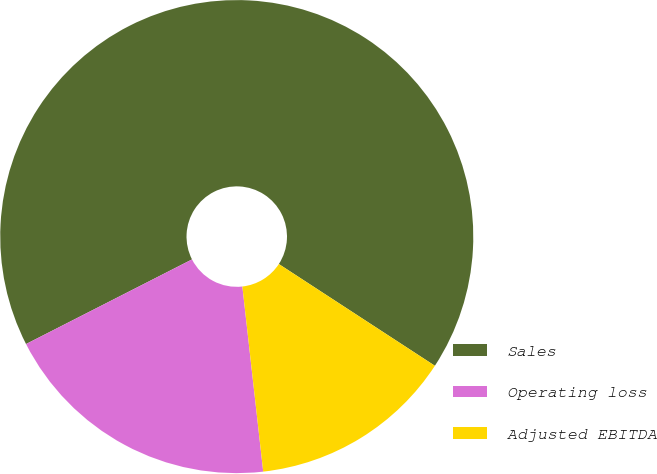Convert chart. <chart><loc_0><loc_0><loc_500><loc_500><pie_chart><fcel>Sales<fcel>Operating loss<fcel>Adjusted EBITDA<nl><fcel>66.7%<fcel>19.28%<fcel>14.02%<nl></chart> 